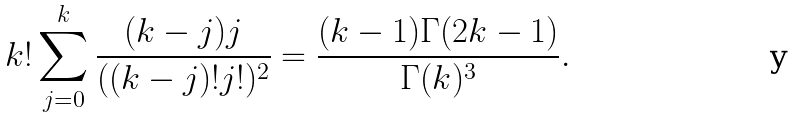Convert formula to latex. <formula><loc_0><loc_0><loc_500><loc_500>k ! \sum _ { j = 0 } ^ { k } \frac { ( k - j ) j } { ( ( k - j ) ! j ! ) ^ { 2 } } = \frac { ( k - 1 ) \Gamma ( 2 k - 1 ) } { \Gamma ( k ) ^ { 3 } } .</formula> 